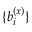<formula> <loc_0><loc_0><loc_500><loc_500>\{ b _ { i } ^ { ( x ) } \}</formula> 